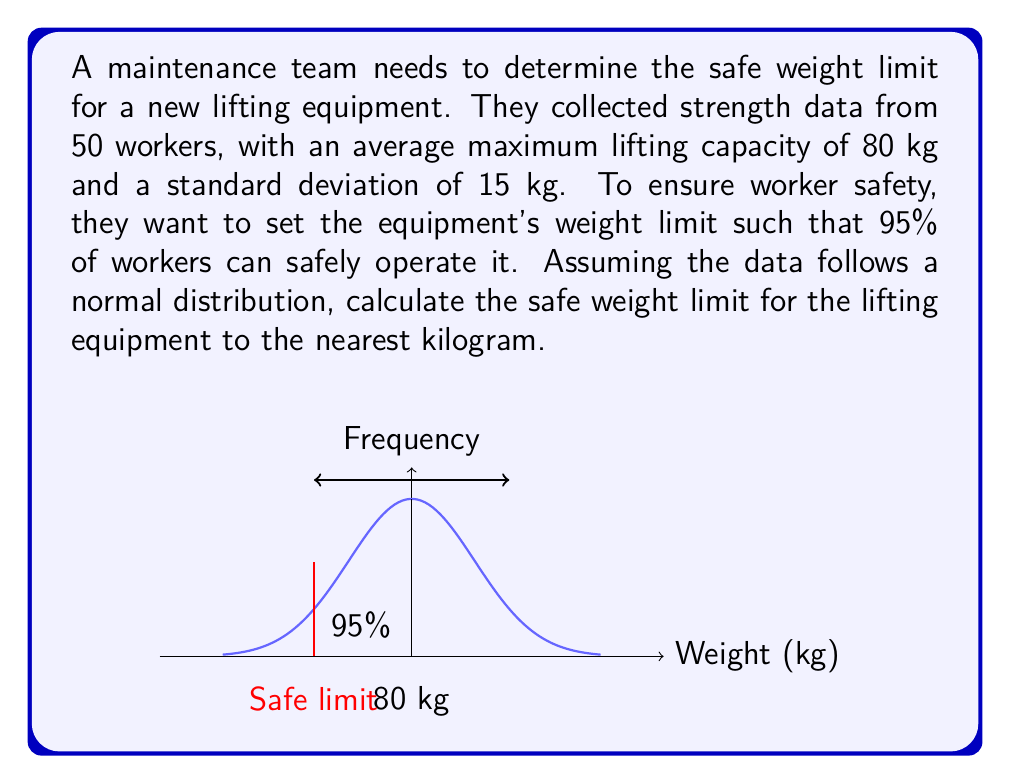Can you solve this math problem? To solve this problem, we'll use the properties of the normal distribution and the concept of z-scores.

1) We're given:
   - Mean (μ) = 80 kg
   - Standard deviation (σ) = 15 kg
   - Desired percentile = 5th (since we want 95% of workers to be able to safely operate it)

2) For a normal distribution, the z-score for the 5th percentile is -1.645.

3) We can use the z-score formula to find the safe weight limit (x):

   $$z = \frac{x - \mu}{\sigma}$$

4) Substituting our values:

   $$-1.645 = \frac{x - 80}{15}$$

5) Solving for x:

   $$-1.645 * 15 = x - 80$$
   $$-24.675 = x - 80$$
   $$x = 80 - 24.675$$
   $$x = 55.325 \text{ kg}$$

6) Rounding to the nearest kilogram:

   Safe weight limit = 56 kg

This limit ensures that 95% of the workers can safely operate the equipment, prioritizing worker safety.
Answer: 56 kg 